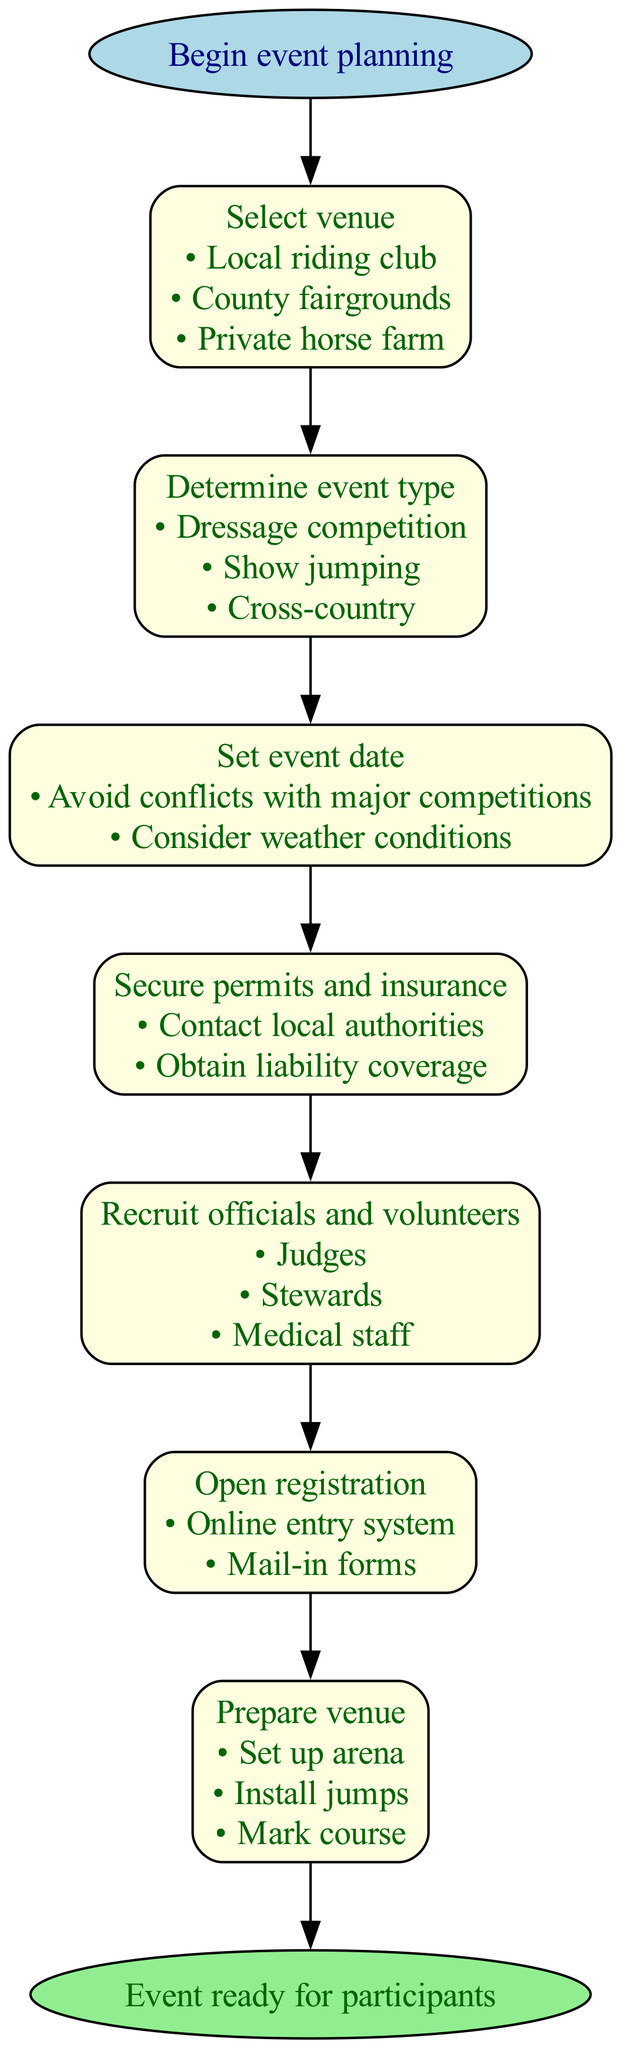What is the first step in the diagram? The first step is indicated as moving from the "start" node to the first box labeled "Select venue." This implies that "Select venue" is the first action in organizing the event.
Answer: Select venue How many venues can be selected? The "Select venue" node lists three options: "Local riding club," "County fairgrounds," and "Private horse farm." Counting these options gives us the total number of venues that can be selected.
Answer: 3 What are the two event types mentioned in the diagram? The "Determine event type" node presents three options: "Dressage competition," "Show jumping," and "Cross-country." Therefore, any two of these options can be chosen.
Answer: Dressage competition, Show jumping What tasks must be completed to secure permits and insurance? The "Secure permits and insurance" node specifies two tasks: "Contact local authorities" and "Obtain liability coverage." This means both tasks are essential for this step.
Answer: Contact local authorities, Obtain liability coverage How many roles are listed for recruitment? The "Recruit officials and volunteers" node lists three roles: "Judges," "Stewards," and "Medical staff." Counting these roles indicates how many people need to be recruited for the event.
Answer: 3 What should be avoided when setting the event date? The "Set event date" node outlines two considerations: "Avoid conflicts with major competitions" and "Consider weather conditions." This suggests that both factors are relevant to scheduling.
Answer: Conflicts with major competitions Which methods can be used for opening registration? The "Open registration" node lists two methods: "Online entry system" and "Mail-in forms." This indicates that event organizers can choose between these two registration methods.
Answer: Online entry system, Mail-in forms What is the last step before the event is ready for participants? The final step indicated in the diagram is moving from the last process, "Prepare venue," to the end node. This indicates that the preparation of the venue must be completed last.
Answer: Prepare venue 